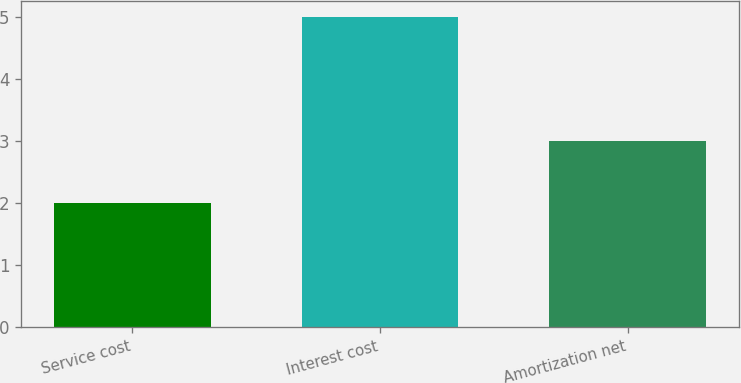Convert chart. <chart><loc_0><loc_0><loc_500><loc_500><bar_chart><fcel>Service cost<fcel>Interest cost<fcel>Amortization net<nl><fcel>2<fcel>5<fcel>3<nl></chart> 